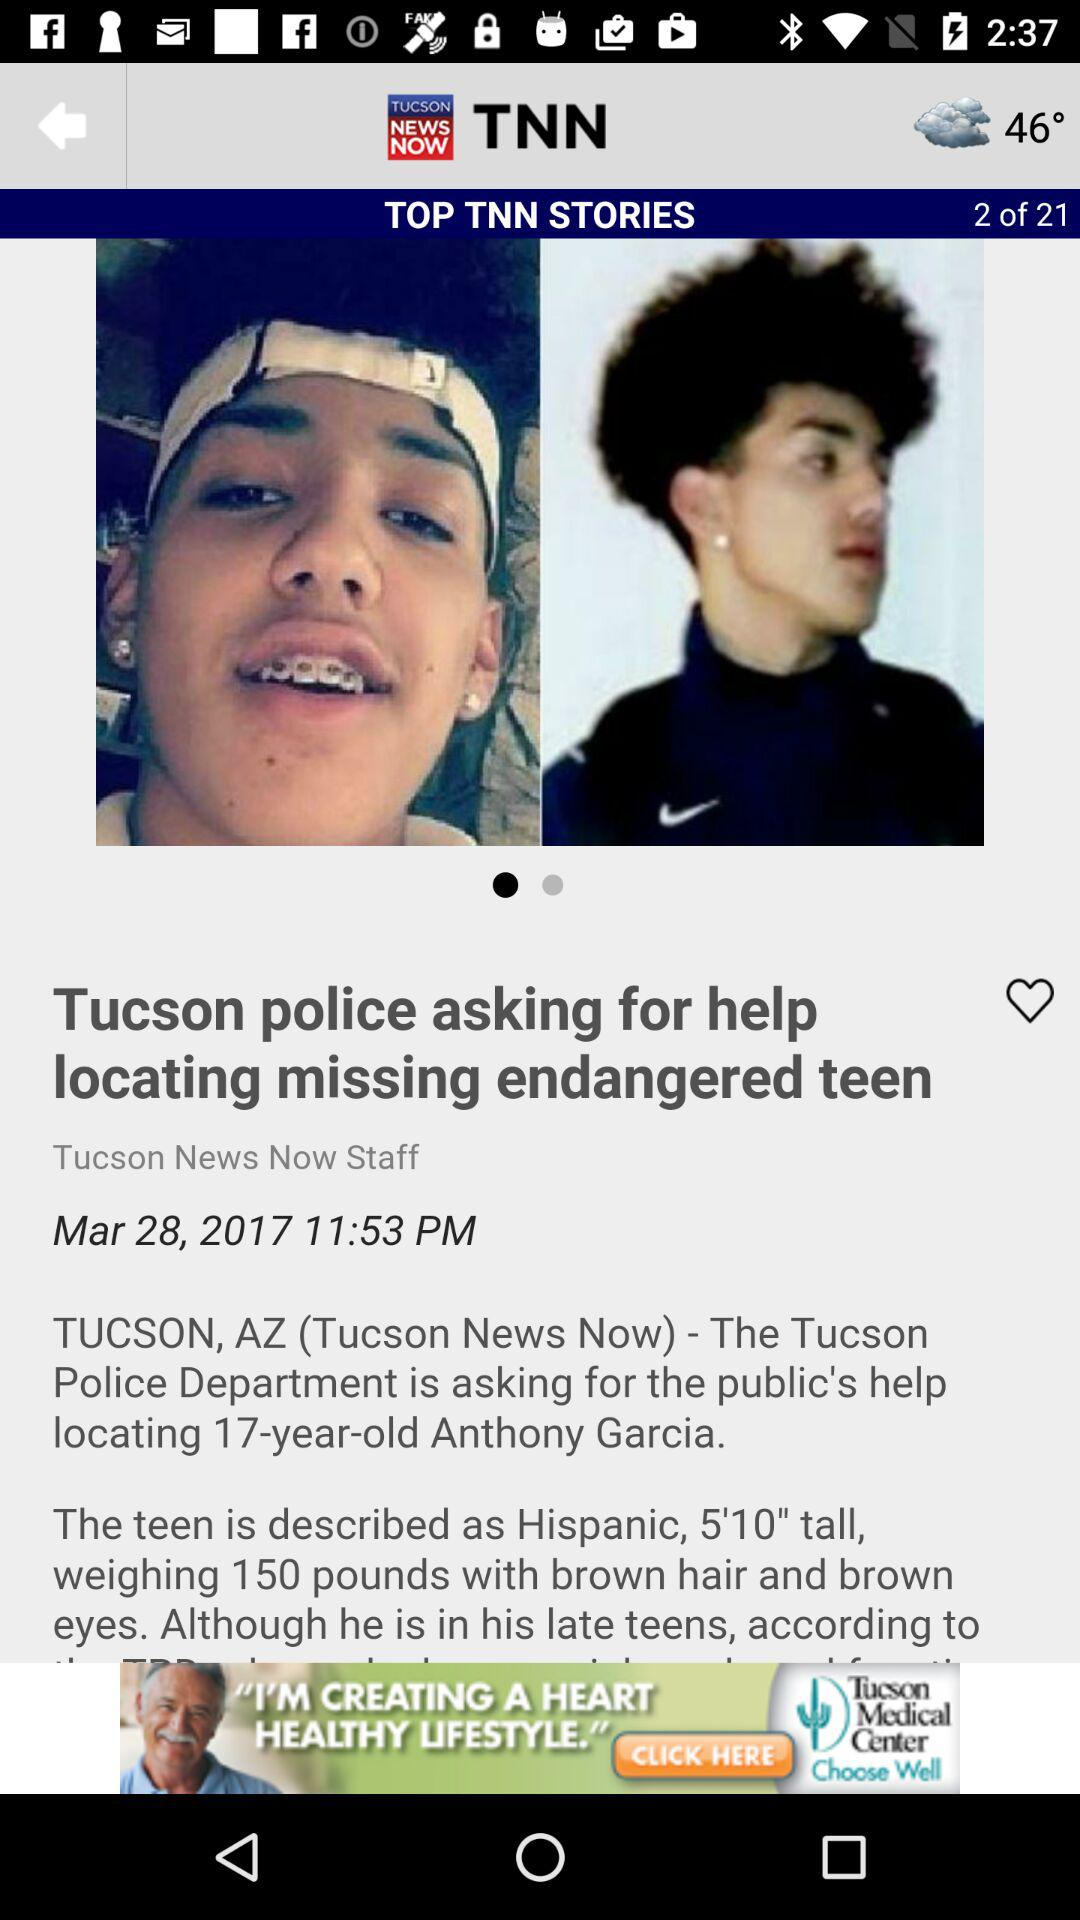How tall is Anthony? Anthony is 5 feet 10 inches tall. 